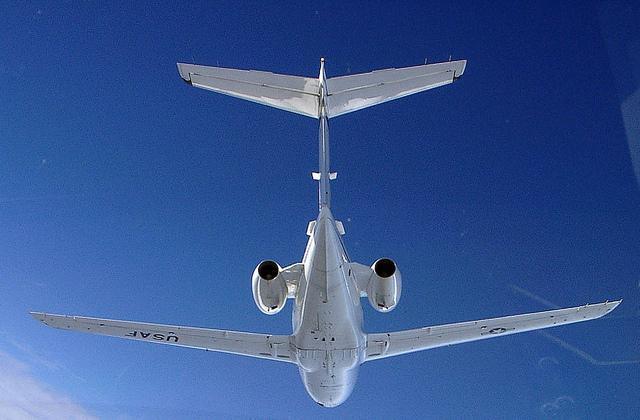How many people on this boat are visible?
Give a very brief answer. 0. 